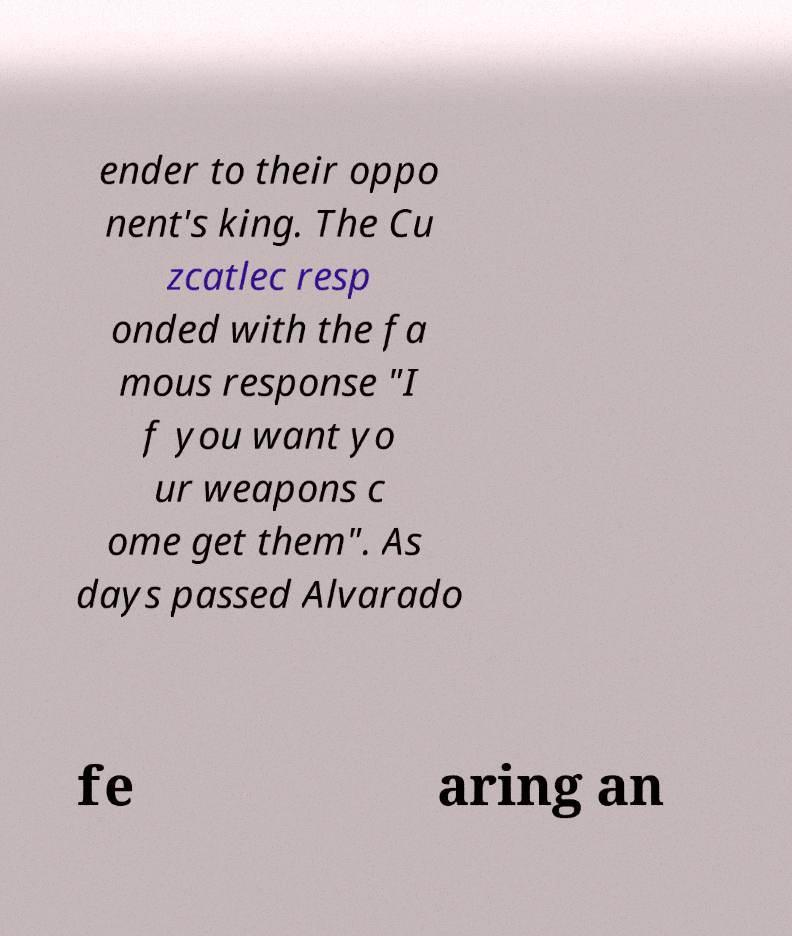What messages or text are displayed in this image? I need them in a readable, typed format. ender to their oppo nent's king. The Cu zcatlec resp onded with the fa mous response "I f you want yo ur weapons c ome get them". As days passed Alvarado fe aring an 